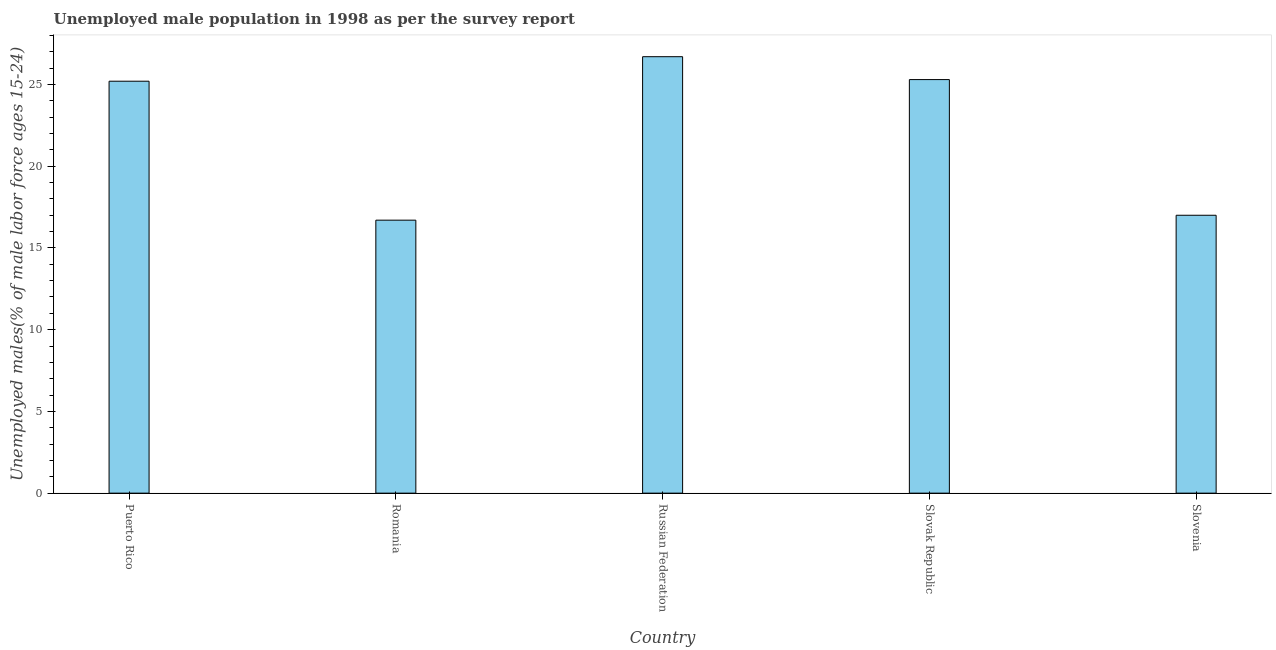Does the graph contain any zero values?
Offer a very short reply. No. What is the title of the graph?
Your answer should be very brief. Unemployed male population in 1998 as per the survey report. What is the label or title of the X-axis?
Offer a very short reply. Country. What is the label or title of the Y-axis?
Keep it short and to the point. Unemployed males(% of male labor force ages 15-24). What is the unemployed male youth in Slovenia?
Ensure brevity in your answer.  17. Across all countries, what is the maximum unemployed male youth?
Your response must be concise. 26.7. Across all countries, what is the minimum unemployed male youth?
Your answer should be compact. 16.7. In which country was the unemployed male youth maximum?
Make the answer very short. Russian Federation. In which country was the unemployed male youth minimum?
Provide a short and direct response. Romania. What is the sum of the unemployed male youth?
Give a very brief answer. 110.9. What is the difference between the unemployed male youth in Puerto Rico and Slovak Republic?
Your answer should be very brief. -0.1. What is the average unemployed male youth per country?
Ensure brevity in your answer.  22.18. What is the median unemployed male youth?
Make the answer very short. 25.2. In how many countries, is the unemployed male youth greater than 16 %?
Offer a very short reply. 5. What is the ratio of the unemployed male youth in Slovak Republic to that in Slovenia?
Give a very brief answer. 1.49. Is the unemployed male youth in Puerto Rico less than that in Slovak Republic?
Your answer should be very brief. Yes. What is the difference between the highest and the second highest unemployed male youth?
Your answer should be very brief. 1.4. Is the sum of the unemployed male youth in Puerto Rico and Romania greater than the maximum unemployed male youth across all countries?
Offer a terse response. Yes. How many bars are there?
Give a very brief answer. 5. Are all the bars in the graph horizontal?
Offer a terse response. No. What is the Unemployed males(% of male labor force ages 15-24) in Puerto Rico?
Make the answer very short. 25.2. What is the Unemployed males(% of male labor force ages 15-24) of Romania?
Your answer should be compact. 16.7. What is the Unemployed males(% of male labor force ages 15-24) of Russian Federation?
Ensure brevity in your answer.  26.7. What is the Unemployed males(% of male labor force ages 15-24) in Slovak Republic?
Provide a short and direct response. 25.3. What is the difference between the Unemployed males(% of male labor force ages 15-24) in Puerto Rico and Romania?
Your answer should be compact. 8.5. What is the difference between the Unemployed males(% of male labor force ages 15-24) in Puerto Rico and Russian Federation?
Give a very brief answer. -1.5. What is the difference between the Unemployed males(% of male labor force ages 15-24) in Romania and Slovak Republic?
Provide a short and direct response. -8.6. What is the difference between the Unemployed males(% of male labor force ages 15-24) in Russian Federation and Slovak Republic?
Ensure brevity in your answer.  1.4. What is the difference between the Unemployed males(% of male labor force ages 15-24) in Slovak Republic and Slovenia?
Your answer should be very brief. 8.3. What is the ratio of the Unemployed males(% of male labor force ages 15-24) in Puerto Rico to that in Romania?
Offer a terse response. 1.51. What is the ratio of the Unemployed males(% of male labor force ages 15-24) in Puerto Rico to that in Russian Federation?
Your answer should be very brief. 0.94. What is the ratio of the Unemployed males(% of male labor force ages 15-24) in Puerto Rico to that in Slovenia?
Ensure brevity in your answer.  1.48. What is the ratio of the Unemployed males(% of male labor force ages 15-24) in Romania to that in Slovak Republic?
Make the answer very short. 0.66. What is the ratio of the Unemployed males(% of male labor force ages 15-24) in Romania to that in Slovenia?
Provide a succinct answer. 0.98. What is the ratio of the Unemployed males(% of male labor force ages 15-24) in Russian Federation to that in Slovak Republic?
Make the answer very short. 1.05. What is the ratio of the Unemployed males(% of male labor force ages 15-24) in Russian Federation to that in Slovenia?
Give a very brief answer. 1.57. What is the ratio of the Unemployed males(% of male labor force ages 15-24) in Slovak Republic to that in Slovenia?
Provide a succinct answer. 1.49. 